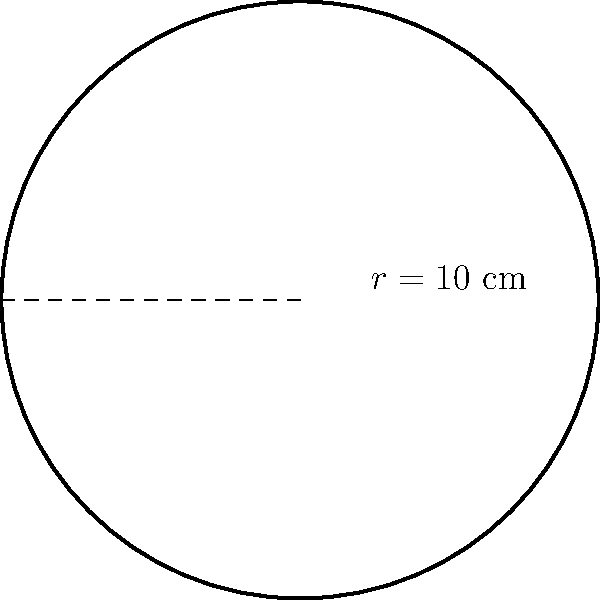For your latest avant-garde hat design, you've created a circular leather brim. If the radius of the brim is 10 cm, what is its perimeter? Round your answer to the nearest centimeter. To find the perimeter of a circular leather cutout, we need to calculate its circumference. The formula for the circumference of a circle is:

$$C = 2\pi r$$

Where:
$C$ is the circumference (perimeter)
$\pi$ is approximately 3.14159
$r$ is the radius

Given:
$r = 10$ cm

Step 1: Substitute the values into the formula
$$C = 2\pi(10)$$

Step 2: Calculate
$$C = 20\pi$$
$$C \approx 20(3.14159)$$
$$C \approx 62.8318 \text{ cm}$$

Step 3: Round to the nearest centimeter
$$C \approx 63 \text{ cm}$$

Therefore, the perimeter of the circular leather brim is approximately 63 cm.
Answer: 63 cm 